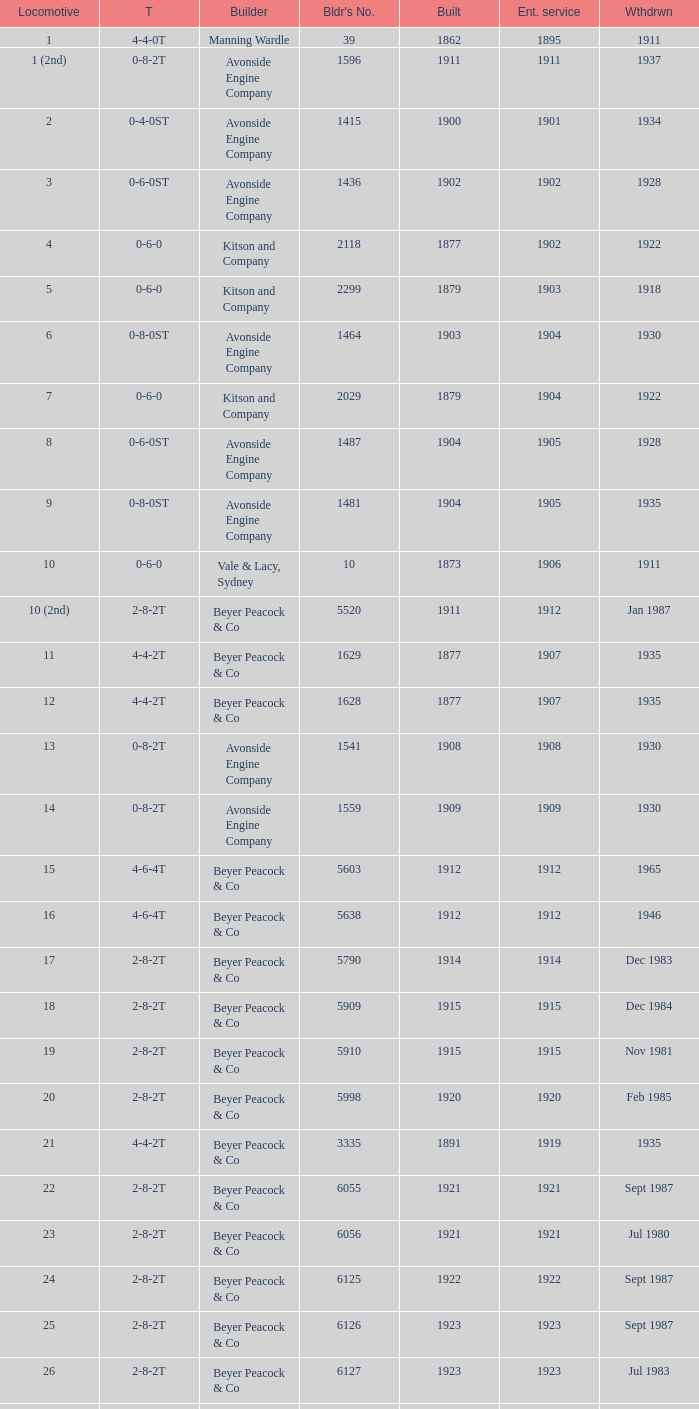Which locomotive had a 2-8-2t type, entered service year prior to 1915, and which was built after 1911? 17.0. 